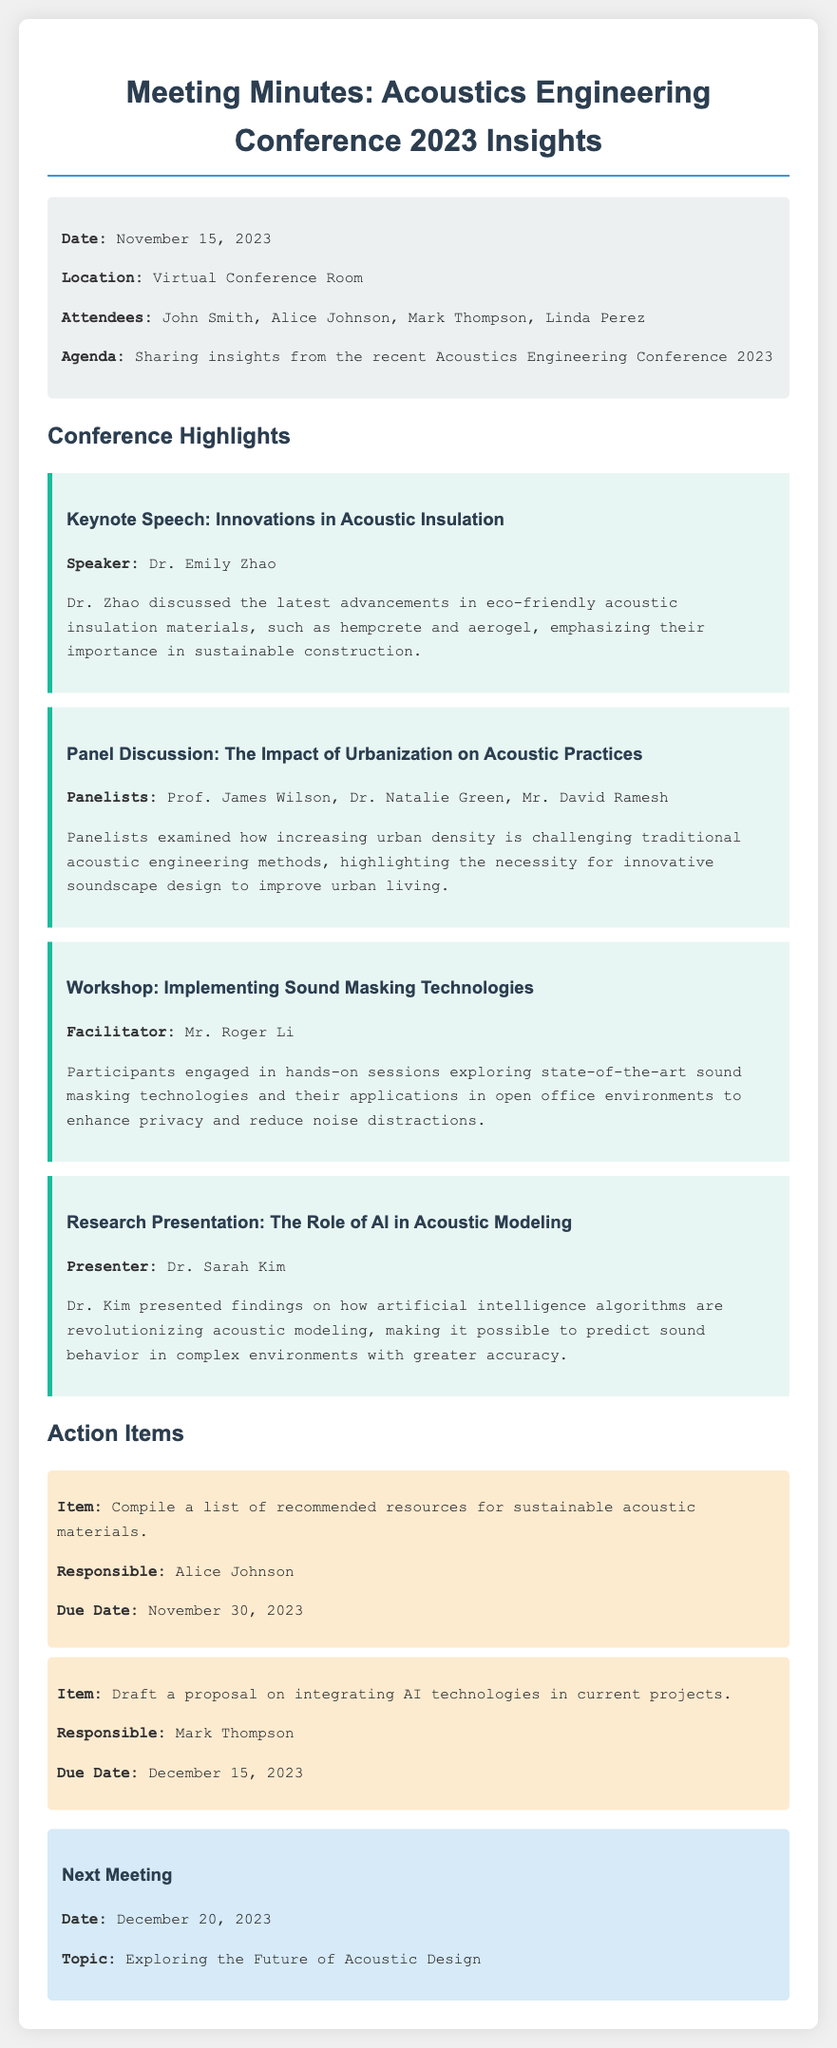What is the date of the meeting? The date of the meeting is provided at the top of the document in the info section.
Answer: November 15, 2023 Who was the speaker of the keynote speech? The keynote speech details include the speaker's name, found under the Keynote Speech section.
Answer: Dr. Emily Zhao What was discussed in the panel discussion? The panel discussion highlights the main topic addressed by the panelists, found in the respective section.
Answer: The Impact of Urbanization on Acoustic Practices Who is responsible for compiling sustainable acoustic materials? The responsible person for the action item regarding sustainable materials is listed in the action items section.
Answer: Alice Johnson When is the next meeting scheduled? The information about the next meeting is found in the last section of the document.
Answer: December 20, 2023 What technology was explored during the workshop? The technology discussed during the workshop is mentioned in the workshop section of the document.
Answer: Sound Masking Technologies What is the title of the research presentation? The title of the research presentation is specified in the highlighted section of the document.
Answer: The Role of AI in Acoustic Modeling How many attendees participated in the meeting? The number of attendees is noted in the info section detailing participants present.
Answer: Four What is the due date for the proposal draft? The due date for the action item regarding the proposal is found in the action items section.
Answer: December 15, 2023 